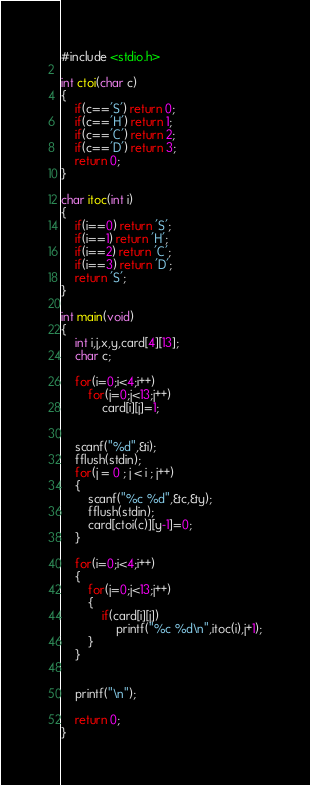Convert code to text. <code><loc_0><loc_0><loc_500><loc_500><_C_>#include <stdio.h>

int ctoi(char c)
{
	if(c=='S') return 0;
	if(c=='H') return 1;
	if(c=='C') return 2;
	if(c=='D') return 3;
	return 0;
}

char itoc(int i)
{
	if(i==0) return 'S';
	if(i==1) return 'H';
	if(i==2) return 'C';
	if(i==3) return 'D';
	return 'S';
}

int main(void)
{
	int i,j,x,y,card[4][13];
	char c;
	
	for(i=0;i<4;i++)
		for(j=0;j<13;j++)
			card[i][j]=1;
		
	
	scanf("%d",&i);
	fflush(stdin);
	for(j = 0 ; j < i ; j++)
	{
		scanf("%c %d",&c,&y);
		fflush(stdin);
		card[ctoi(c)][y-1]=0;
	}
	
	for(i=0;i<4;i++)
	{
		for(j=0;j<13;j++)
		{
			if(card[i][j])
				printf("%c %d\n",itoc(i),j+1);
		}
	}
	
	
	printf("\n");
	
	return 0;
}</code> 